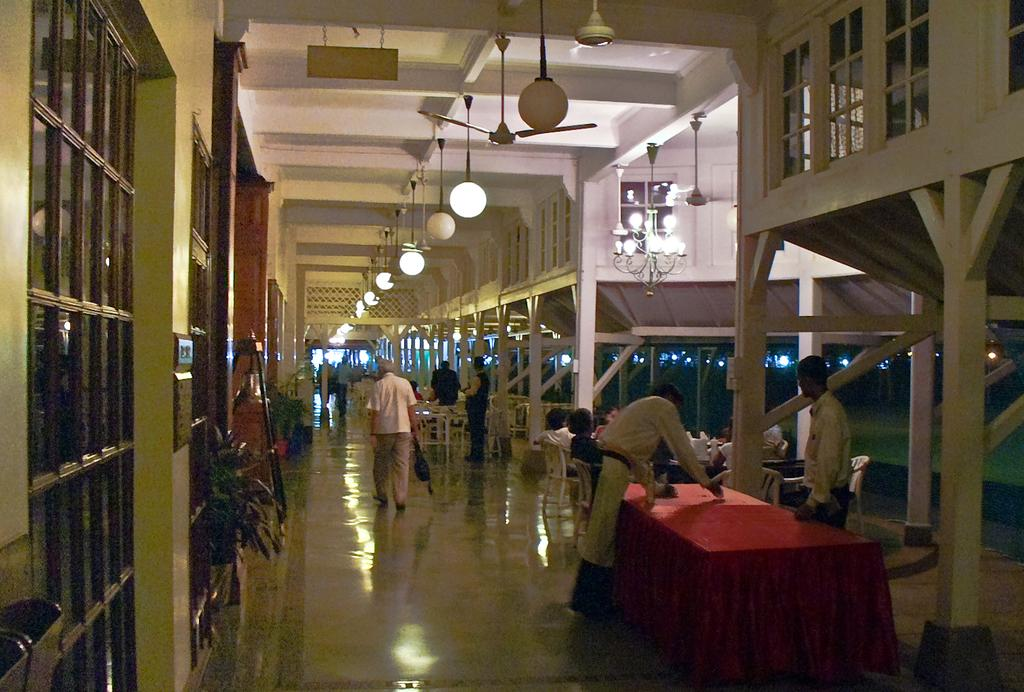How many persons are sitting in the chair in the image? There is a group of persons sitting in a chair in the image. What is in front of the sitting persons? There is a table in front of the sitting persons. What are the standing persons doing in the image? There are some persons standing behind the table. What type of sheet is being used for learning in the image? There is no sheet or learning activity present in the image. What time of day is it in the image? The time of day cannot be determined from the image. 